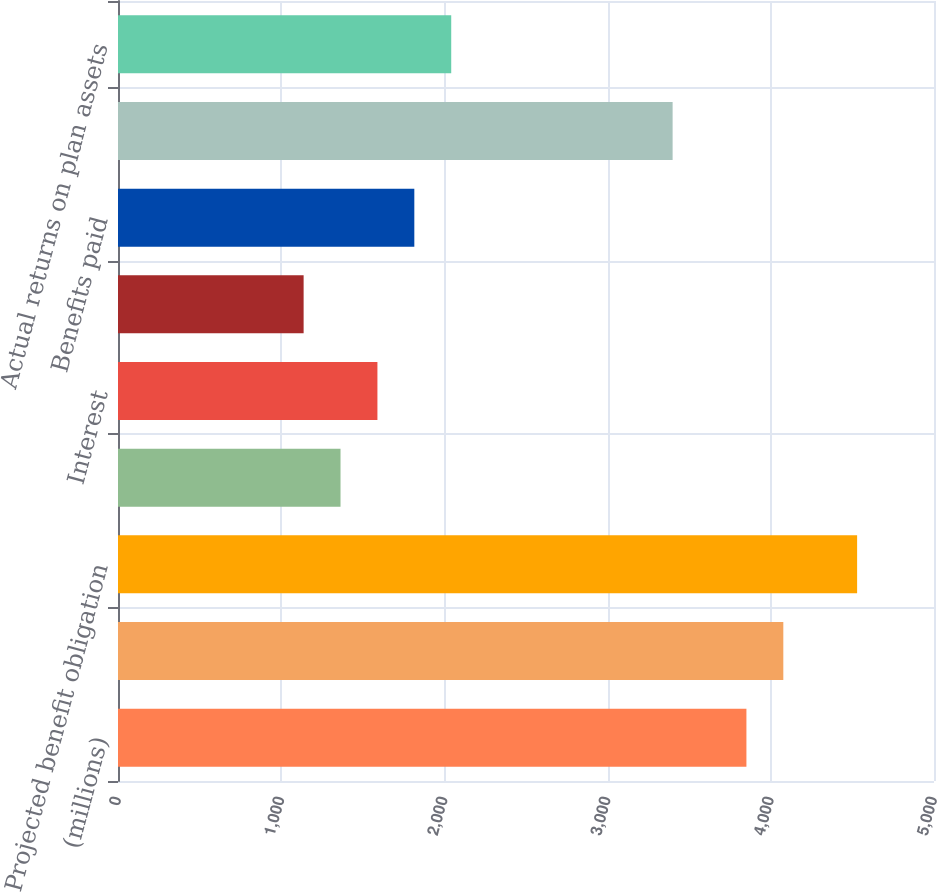<chart> <loc_0><loc_0><loc_500><loc_500><bar_chart><fcel>(millions)<fcel>Accumulated Benefit Obligation<fcel>Projected benefit obligation<fcel>Service cost<fcel>Interest<fcel>Actuarial loss (gain)<fcel>Benefits paid<fcel>Fair value of plan assets<fcel>Actual returns on plan assets<nl><fcel>3850.6<fcel>4076.7<fcel>4528.9<fcel>1363.5<fcel>1589.6<fcel>1137.4<fcel>1815.7<fcel>3398.4<fcel>2041.8<nl></chart> 